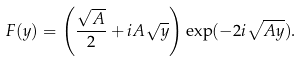Convert formula to latex. <formula><loc_0><loc_0><loc_500><loc_500>F ( y ) = \left ( \frac { \sqrt { A } } { 2 } + i A \sqrt { y } \right ) \exp ( - 2 i \sqrt { A y } ) .</formula> 